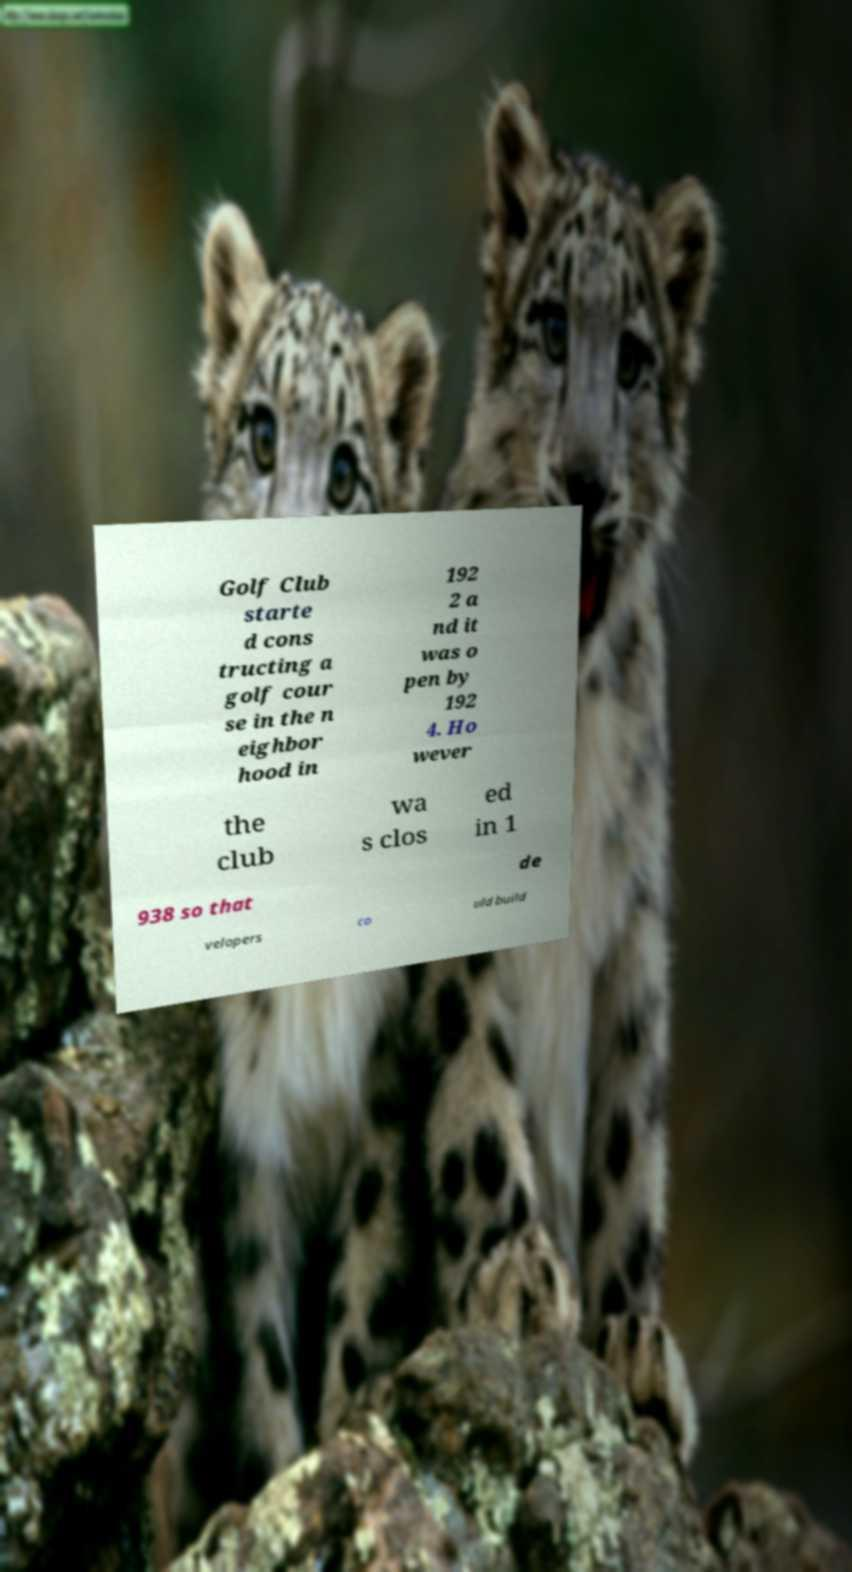Could you extract and type out the text from this image? Golf Club starte d cons tructing a golf cour se in the n eighbor hood in 192 2 a nd it was o pen by 192 4. Ho wever the club wa s clos ed in 1 938 so that de velopers co uld build 